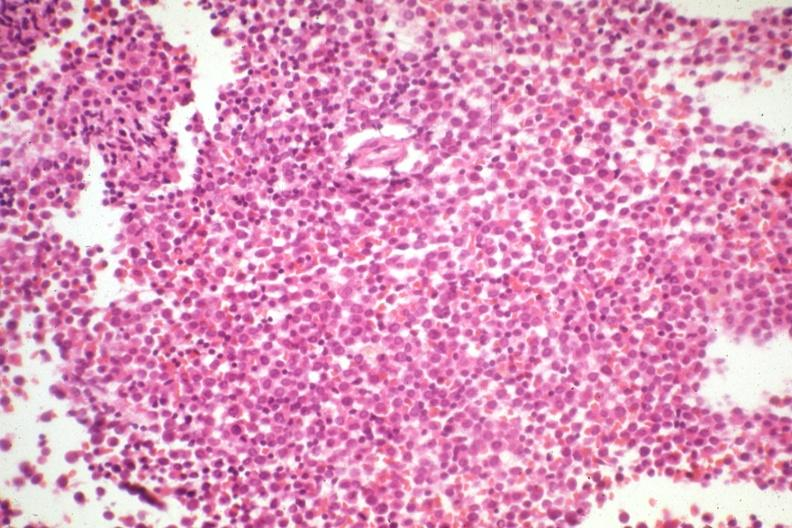s bone marrow present?
Answer the question using a single word or phrase. Yes 